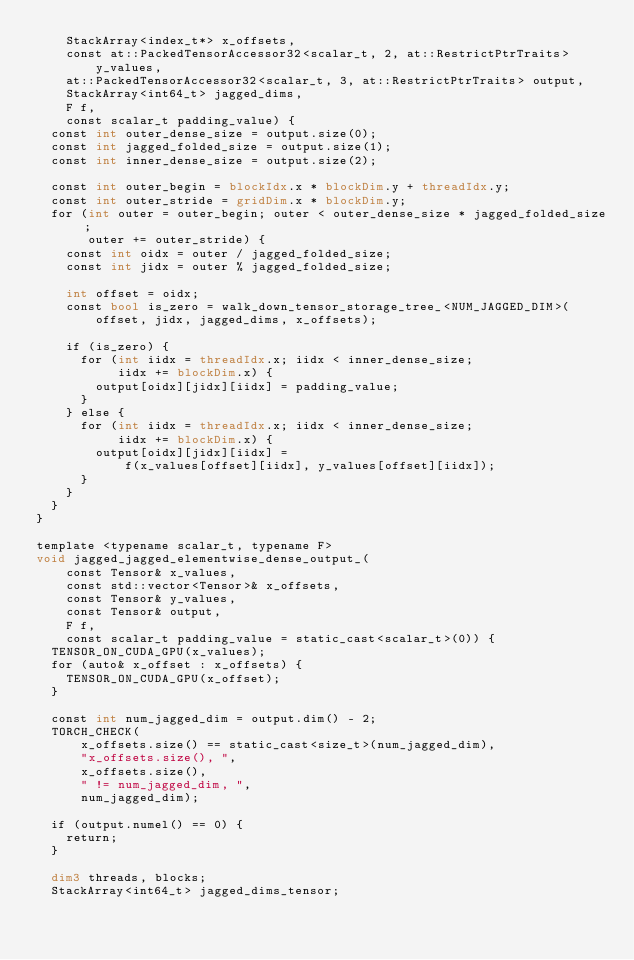Convert code to text. <code><loc_0><loc_0><loc_500><loc_500><_Cuda_>    StackArray<index_t*> x_offsets,
    const at::PackedTensorAccessor32<scalar_t, 2, at::RestrictPtrTraits>
        y_values,
    at::PackedTensorAccessor32<scalar_t, 3, at::RestrictPtrTraits> output,
    StackArray<int64_t> jagged_dims,
    F f,
    const scalar_t padding_value) {
  const int outer_dense_size = output.size(0);
  const int jagged_folded_size = output.size(1);
  const int inner_dense_size = output.size(2);

  const int outer_begin = blockIdx.x * blockDim.y + threadIdx.y;
  const int outer_stride = gridDim.x * blockDim.y;
  for (int outer = outer_begin; outer < outer_dense_size * jagged_folded_size;
       outer += outer_stride) {
    const int oidx = outer / jagged_folded_size;
    const int jidx = outer % jagged_folded_size;

    int offset = oidx;
    const bool is_zero = walk_down_tensor_storage_tree_<NUM_JAGGED_DIM>(
        offset, jidx, jagged_dims, x_offsets);

    if (is_zero) {
      for (int iidx = threadIdx.x; iidx < inner_dense_size;
           iidx += blockDim.x) {
        output[oidx][jidx][iidx] = padding_value;
      }
    } else {
      for (int iidx = threadIdx.x; iidx < inner_dense_size;
           iidx += blockDim.x) {
        output[oidx][jidx][iidx] =
            f(x_values[offset][iidx], y_values[offset][iidx]);
      }
    }
  }
}

template <typename scalar_t, typename F>
void jagged_jagged_elementwise_dense_output_(
    const Tensor& x_values,
    const std::vector<Tensor>& x_offsets,
    const Tensor& y_values,
    const Tensor& output,
    F f,
    const scalar_t padding_value = static_cast<scalar_t>(0)) {
  TENSOR_ON_CUDA_GPU(x_values);
  for (auto& x_offset : x_offsets) {
    TENSOR_ON_CUDA_GPU(x_offset);
  }

  const int num_jagged_dim = output.dim() - 2;
  TORCH_CHECK(
      x_offsets.size() == static_cast<size_t>(num_jagged_dim),
      "x_offsets.size(), ",
      x_offsets.size(),
      " != num_jagged_dim, ",
      num_jagged_dim);

  if (output.numel() == 0) {
    return;
  }

  dim3 threads, blocks;
  StackArray<int64_t> jagged_dims_tensor;</code> 